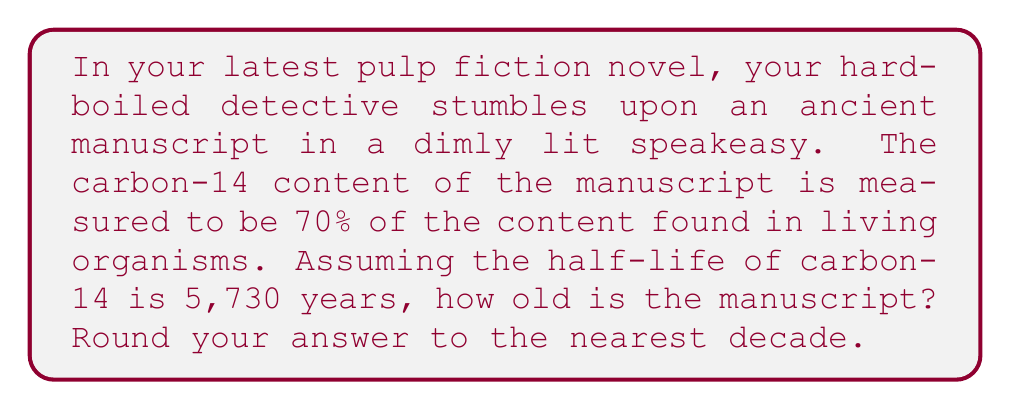Could you help me with this problem? Let's approach this problem step-by-step, using the radiocarbon dating equation:

1) The general equation for radiocarbon dating is:

   $$t = -\frac{\ln(N/N_0)}{\lambda}$$

   Where:
   $t$ is the age of the sample
   $N/N_0$ is the fraction of carbon-14 remaining
   $\lambda$ is the decay constant

2) We're given that $N/N_0 = 0.70$ (70% remaining)

3) We need to calculate $\lambda$ from the half-life:

   $$\lambda = \frac{\ln(2)}{t_{1/2}} = \frac{\ln(2)}{5730} \approx 0.000121$$

4) Now we can plug these values into our equation:

   $$t = -\frac{\ln(0.70)}{0.000121}$$

5) Solving this:

   $$t \approx 2941.7 \text{ years}$$

6) Rounding to the nearest decade:

   $$t \approx 2940 \text{ years}$$
Answer: 2940 years 